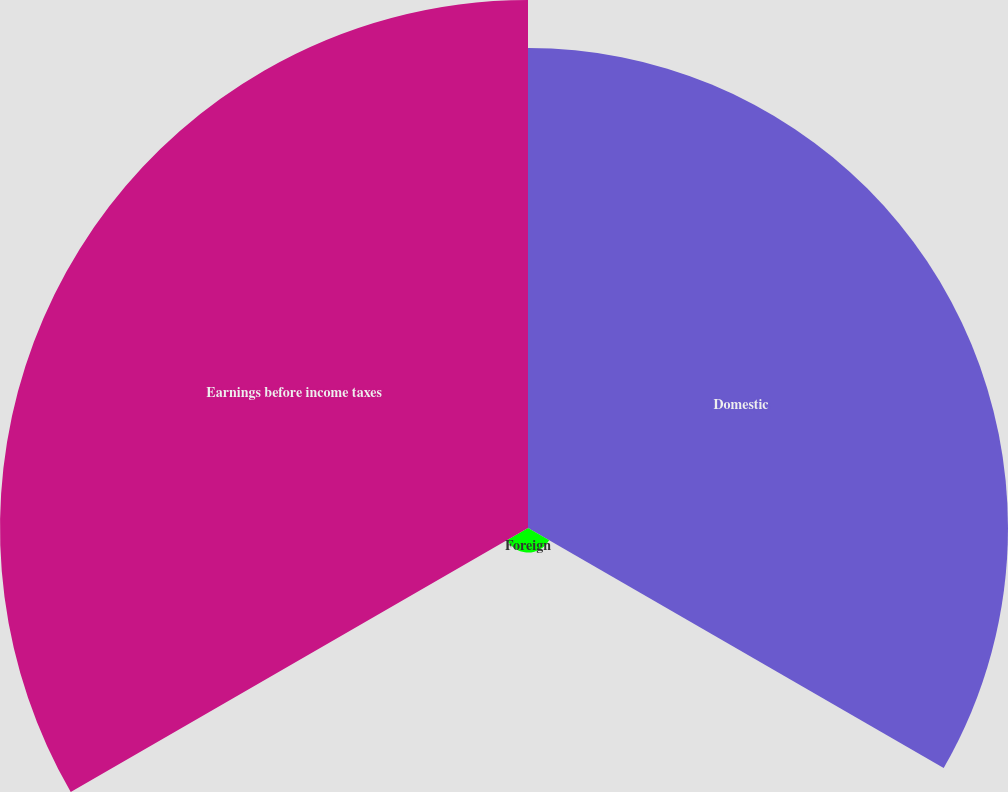<chart> <loc_0><loc_0><loc_500><loc_500><pie_chart><fcel>Domestic<fcel>Foreign<fcel>Earnings before income taxes<nl><fcel>46.49%<fcel>2.37%<fcel>51.14%<nl></chart> 